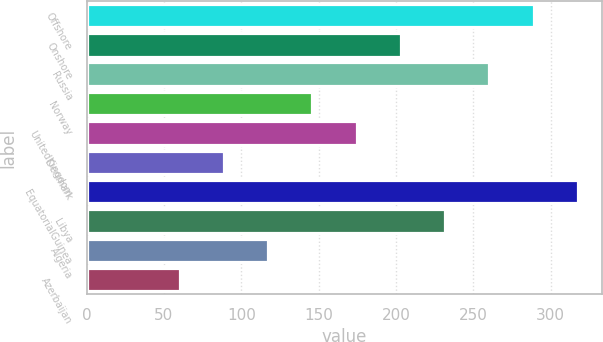Convert chart. <chart><loc_0><loc_0><loc_500><loc_500><bar_chart><fcel>Offshore<fcel>Onshore<fcel>Russia<fcel>Norway<fcel>UnitedKingdom<fcel>Denmark<fcel>EquatorialGuinea<fcel>Libya<fcel>Algeria<fcel>Azerbaijan<nl><fcel>289<fcel>203.2<fcel>260.4<fcel>146<fcel>174.6<fcel>88.8<fcel>317.6<fcel>231.8<fcel>117.4<fcel>60.2<nl></chart> 